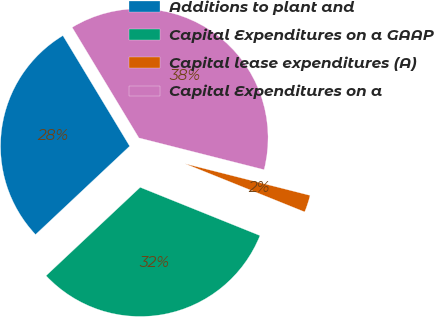Convert chart. <chart><loc_0><loc_0><loc_500><loc_500><pie_chart><fcel>Additions to plant and<fcel>Capital Expenditures on a GAAP<fcel>Capital lease expenditures (A)<fcel>Capital Expenditures on a<nl><fcel>28.35%<fcel>31.9%<fcel>2.14%<fcel>37.6%<nl></chart> 